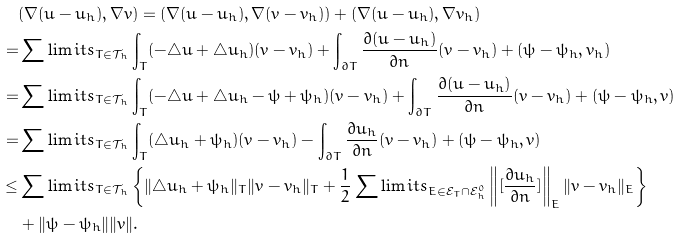Convert formula to latex. <formula><loc_0><loc_0><loc_500><loc_500>& ( \nabla ( u - u _ { h } ) , \nabla v ) = ( \nabla ( u - u _ { h } ) , \nabla ( v - v _ { h } ) ) + ( \nabla ( u - u _ { h } ) , \nabla v _ { h } ) \\ = & \sum \lim i t s _ { T \in \mathcal { T } _ { h } } \int _ { T } ( - \triangle u + \triangle u _ { h } ) ( v - v _ { h } ) + \int _ { \partial T } \frac { \partial ( u - u _ { h } ) } { \partial { n } } ( v - v _ { h } ) + ( \psi - \psi _ { h } , v _ { h } ) \\ = & \sum \lim i t s _ { T \in \mathcal { T } _ { h } } \int _ { T } ( - \triangle u + \triangle u _ { h } - \psi + \psi _ { h } ) ( v - v _ { h } ) + \int _ { \partial T } \frac { \partial ( u - u _ { h } ) } { \partial { n } } ( v - v _ { h } ) + ( \psi - \psi _ { h } , v ) \\ = & \sum \lim i t s _ { T \in \mathcal { T } _ { h } } \int _ { T } ( \triangle u _ { h } + \psi _ { h } ) ( v - v _ { h } ) - \int _ { \partial T } \frac { \partial u _ { h } } { \partial { n } } ( v - v _ { h } ) + ( \psi - \psi _ { h } , v ) \\ \leq & \sum \lim i t s _ { T \in \mathcal { T } _ { h } } \left \{ \| \triangle u _ { h } + \psi _ { h } \| _ { T } \| v - v _ { h } \| _ { T } + \frac { 1 } { 2 } \sum \lim i t s _ { E \in \mathcal { E } _ { T } \cap \mathcal { E } _ { h } ^ { 0 } } \left \| [ \frac { \partial u _ { h } } { \partial { n } } ] \right \| _ { E } \| v - v _ { h } \| _ { E } \right \} \\ & + \| \psi - \psi _ { h } \| \| v \| .</formula> 